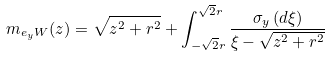Convert formula to latex. <formula><loc_0><loc_0><loc_500><loc_500>m _ { e _ { y } W } ( z ) = \sqrt { z ^ { 2 } + r ^ { 2 } } + \int _ { - \sqrt { 2 } r } ^ { \sqrt { 2 } r } \frac { \sigma _ { y } \left ( d \xi \right ) } { \xi - \sqrt { z ^ { 2 } + r ^ { 2 } } }</formula> 